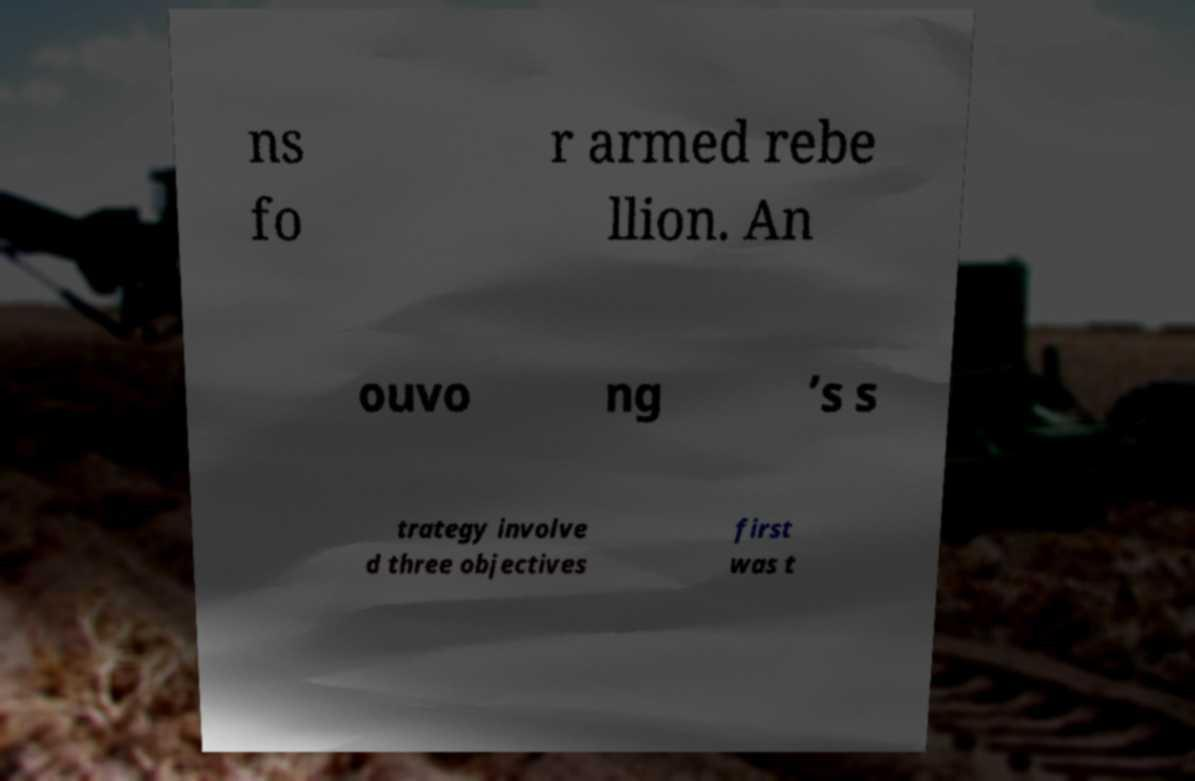Please read and relay the text visible in this image. What does it say? ns fo r armed rebe llion. An ouvo ng ’s s trategy involve d three objectives first was t 